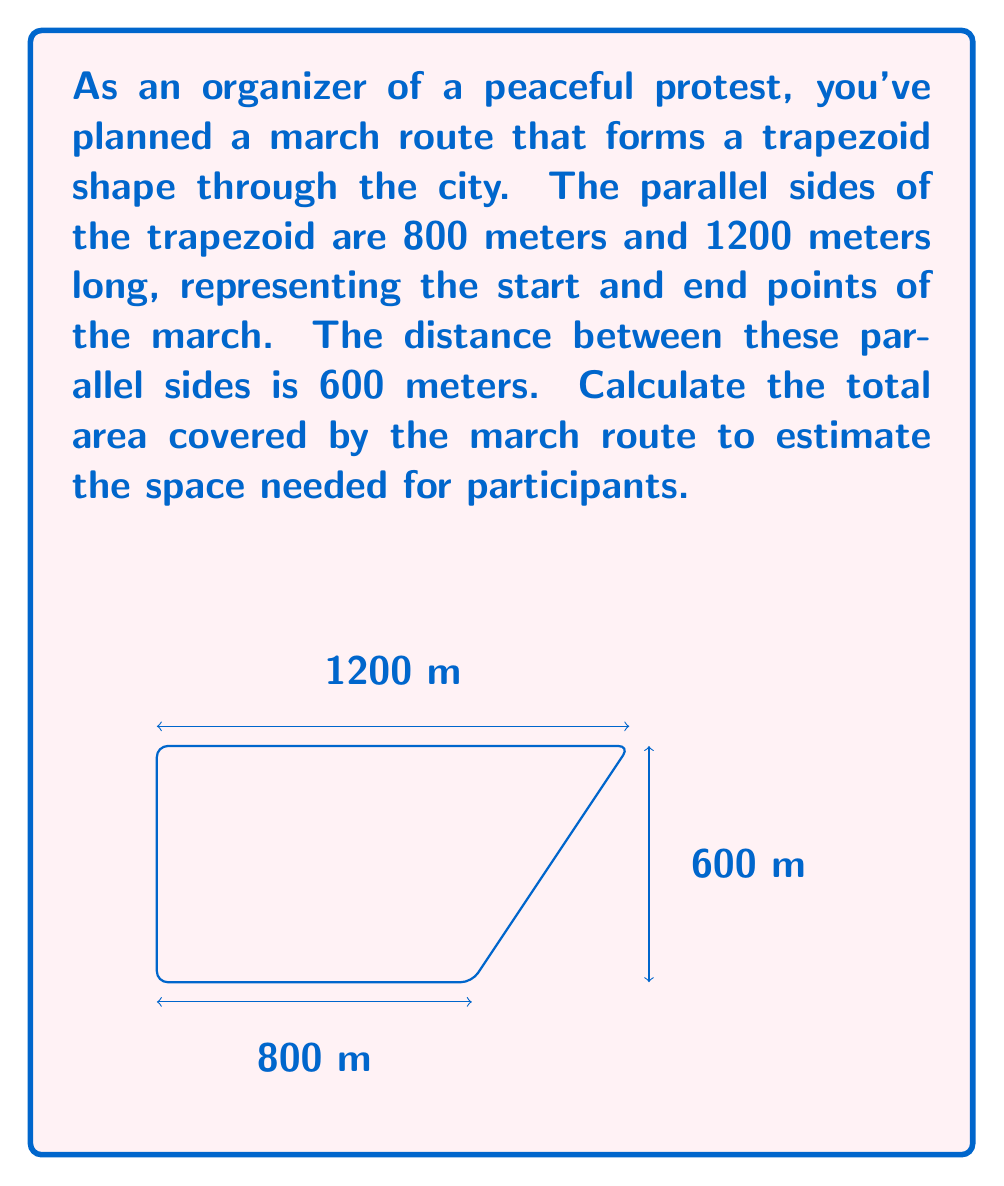What is the answer to this math problem? To solve this problem, we'll use the formula for the area of a trapezoid:

$$A = \frac{1}{2}(b_1 + b_2)h$$

Where:
$A$ = area of the trapezoid
$b_1$ and $b_2$ = lengths of the parallel sides
$h$ = height (perpendicular distance between the parallel sides)

Given:
$b_1 = 800$ meters
$b_2 = 1200$ meters
$h = 600$ meters

Let's substitute these values into the formula:

$$A = \frac{1}{2}(800 + 1200) \times 600$$

Simplify inside the parentheses:
$$A = \frac{1}{2}(2000) \times 600$$

Multiply:
$$A = 1000 \times 600$$

Calculate the final result:
$$A = 600,000 \text{ square meters}$$

Therefore, the total area covered by the march route is 600,000 square meters.
Answer: 600,000 m² 